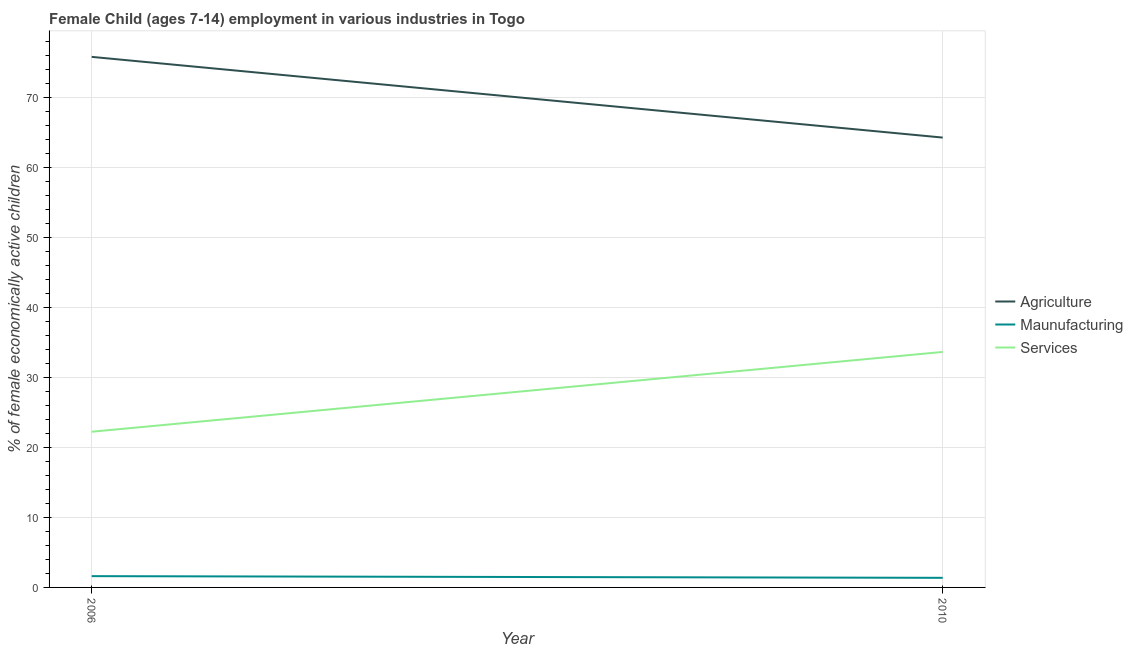How many different coloured lines are there?
Give a very brief answer. 3. Is the number of lines equal to the number of legend labels?
Your answer should be very brief. Yes. What is the percentage of economically active children in agriculture in 2006?
Give a very brief answer. 75.79. Across all years, what is the maximum percentage of economically active children in agriculture?
Your answer should be very brief. 75.79. Across all years, what is the minimum percentage of economically active children in services?
Provide a short and direct response. 22.24. What is the total percentage of economically active children in services in the graph?
Provide a succinct answer. 55.88. What is the difference between the percentage of economically active children in manufacturing in 2006 and that in 2010?
Your response must be concise. 0.24. What is the difference between the percentage of economically active children in agriculture in 2010 and the percentage of economically active children in manufacturing in 2006?
Give a very brief answer. 62.65. What is the average percentage of economically active children in services per year?
Make the answer very short. 27.94. In the year 2006, what is the difference between the percentage of economically active children in manufacturing and percentage of economically active children in services?
Offer a very short reply. -20.63. In how many years, is the percentage of economically active children in services greater than 30 %?
Provide a short and direct response. 1. What is the ratio of the percentage of economically active children in agriculture in 2006 to that in 2010?
Make the answer very short. 1.18. Is the percentage of economically active children in agriculture in 2006 less than that in 2010?
Give a very brief answer. No. Is the percentage of economically active children in manufacturing strictly greater than the percentage of economically active children in services over the years?
Keep it short and to the point. No. Is the percentage of economically active children in services strictly less than the percentage of economically active children in manufacturing over the years?
Ensure brevity in your answer.  No. How many lines are there?
Ensure brevity in your answer.  3. How many years are there in the graph?
Ensure brevity in your answer.  2. Are the values on the major ticks of Y-axis written in scientific E-notation?
Keep it short and to the point. No. Does the graph contain any zero values?
Keep it short and to the point. No. What is the title of the graph?
Your response must be concise. Female Child (ages 7-14) employment in various industries in Togo. What is the label or title of the X-axis?
Offer a very short reply. Year. What is the label or title of the Y-axis?
Ensure brevity in your answer.  % of female economically active children. What is the % of female economically active children in Agriculture in 2006?
Provide a short and direct response. 75.79. What is the % of female economically active children in Maunufacturing in 2006?
Keep it short and to the point. 1.61. What is the % of female economically active children in Services in 2006?
Ensure brevity in your answer.  22.24. What is the % of female economically active children in Agriculture in 2010?
Offer a very short reply. 64.26. What is the % of female economically active children of Maunufacturing in 2010?
Offer a terse response. 1.37. What is the % of female economically active children in Services in 2010?
Your answer should be compact. 33.64. Across all years, what is the maximum % of female economically active children in Agriculture?
Ensure brevity in your answer.  75.79. Across all years, what is the maximum % of female economically active children of Maunufacturing?
Your answer should be very brief. 1.61. Across all years, what is the maximum % of female economically active children in Services?
Provide a succinct answer. 33.64. Across all years, what is the minimum % of female economically active children of Agriculture?
Your answer should be compact. 64.26. Across all years, what is the minimum % of female economically active children of Maunufacturing?
Provide a succinct answer. 1.37. Across all years, what is the minimum % of female economically active children of Services?
Your answer should be very brief. 22.24. What is the total % of female economically active children of Agriculture in the graph?
Your response must be concise. 140.05. What is the total % of female economically active children in Maunufacturing in the graph?
Your answer should be compact. 2.98. What is the total % of female economically active children of Services in the graph?
Keep it short and to the point. 55.88. What is the difference between the % of female economically active children in Agriculture in 2006 and that in 2010?
Make the answer very short. 11.53. What is the difference between the % of female economically active children in Maunufacturing in 2006 and that in 2010?
Offer a very short reply. 0.24. What is the difference between the % of female economically active children of Agriculture in 2006 and the % of female economically active children of Maunufacturing in 2010?
Keep it short and to the point. 74.42. What is the difference between the % of female economically active children in Agriculture in 2006 and the % of female economically active children in Services in 2010?
Your answer should be compact. 42.15. What is the difference between the % of female economically active children of Maunufacturing in 2006 and the % of female economically active children of Services in 2010?
Provide a succinct answer. -32.03. What is the average % of female economically active children of Agriculture per year?
Your response must be concise. 70.03. What is the average % of female economically active children of Maunufacturing per year?
Your answer should be compact. 1.49. What is the average % of female economically active children in Services per year?
Give a very brief answer. 27.94. In the year 2006, what is the difference between the % of female economically active children in Agriculture and % of female economically active children in Maunufacturing?
Keep it short and to the point. 74.18. In the year 2006, what is the difference between the % of female economically active children in Agriculture and % of female economically active children in Services?
Make the answer very short. 53.55. In the year 2006, what is the difference between the % of female economically active children in Maunufacturing and % of female economically active children in Services?
Provide a succinct answer. -20.63. In the year 2010, what is the difference between the % of female economically active children in Agriculture and % of female economically active children in Maunufacturing?
Your response must be concise. 62.89. In the year 2010, what is the difference between the % of female economically active children of Agriculture and % of female economically active children of Services?
Provide a short and direct response. 30.62. In the year 2010, what is the difference between the % of female economically active children of Maunufacturing and % of female economically active children of Services?
Provide a succinct answer. -32.27. What is the ratio of the % of female economically active children of Agriculture in 2006 to that in 2010?
Keep it short and to the point. 1.18. What is the ratio of the % of female economically active children of Maunufacturing in 2006 to that in 2010?
Offer a very short reply. 1.18. What is the ratio of the % of female economically active children of Services in 2006 to that in 2010?
Keep it short and to the point. 0.66. What is the difference between the highest and the second highest % of female economically active children of Agriculture?
Make the answer very short. 11.53. What is the difference between the highest and the second highest % of female economically active children in Maunufacturing?
Ensure brevity in your answer.  0.24. What is the difference between the highest and the second highest % of female economically active children in Services?
Offer a terse response. 11.4. What is the difference between the highest and the lowest % of female economically active children of Agriculture?
Make the answer very short. 11.53. What is the difference between the highest and the lowest % of female economically active children of Maunufacturing?
Ensure brevity in your answer.  0.24. What is the difference between the highest and the lowest % of female economically active children of Services?
Provide a short and direct response. 11.4. 